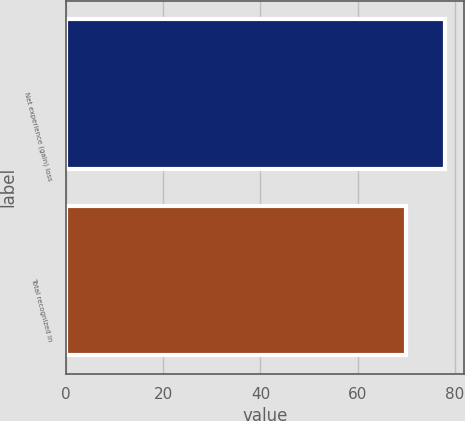Convert chart. <chart><loc_0><loc_0><loc_500><loc_500><bar_chart><fcel>Net experience (gain) loss<fcel>Total recognized in<nl><fcel>78<fcel>70<nl></chart> 